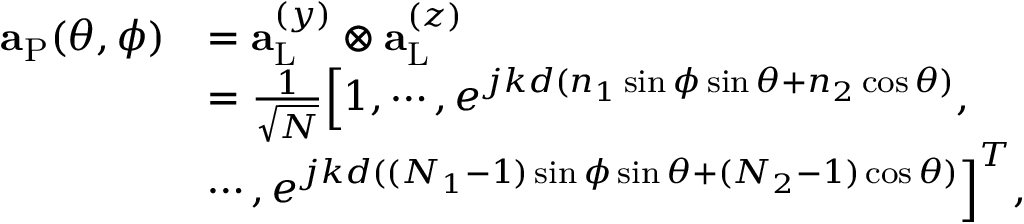Convert formula to latex. <formula><loc_0><loc_0><loc_500><loc_500>\begin{array} { r l } { { a } _ { P } ( \theta , \phi ) } & { = { a } _ { L } ^ { ( y ) } \otimes { a } _ { L } ^ { ( z ) } } \\ & { = \frac { 1 } { \sqrt { N } } \left [ 1 , \cdots , e ^ { j k d ( n _ { 1 } \sin \phi \sin \theta + n _ { 2 } \cos \theta ) } , } \\ & { \cdots , e ^ { j k d ( ( N _ { 1 } - 1 ) \sin \phi \sin \theta + ( N _ { 2 } - 1 ) \cos \theta ) } \right ] ^ { T } , } \end{array}</formula> 